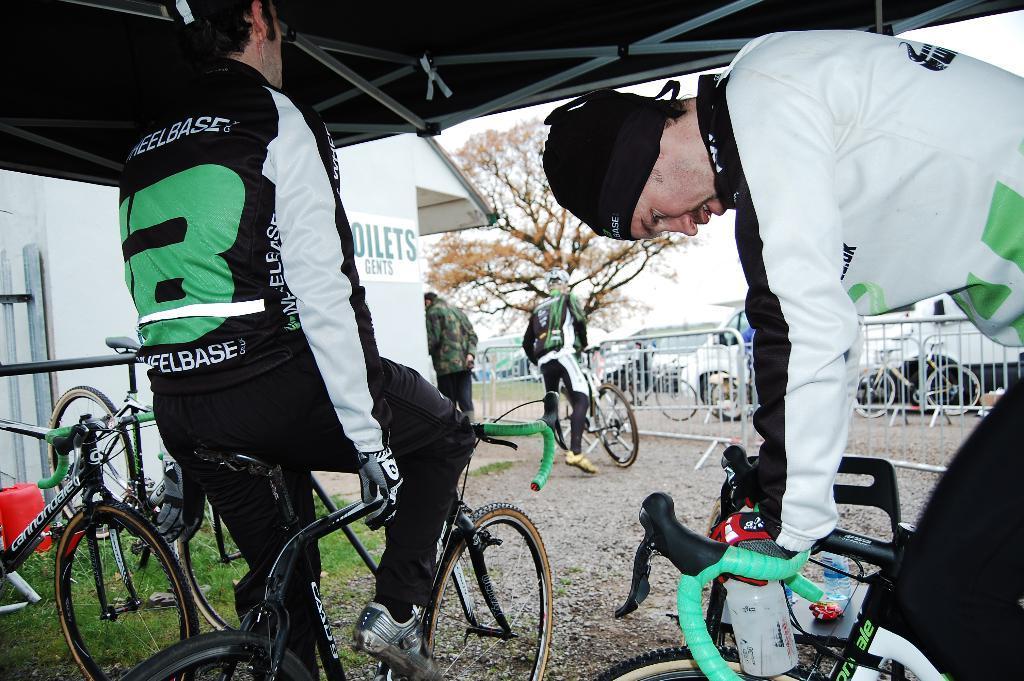Can you describe this image briefly? In the image we can see there are people who are sitting on bicycle and a person is holding a bicycle and there are trees. 